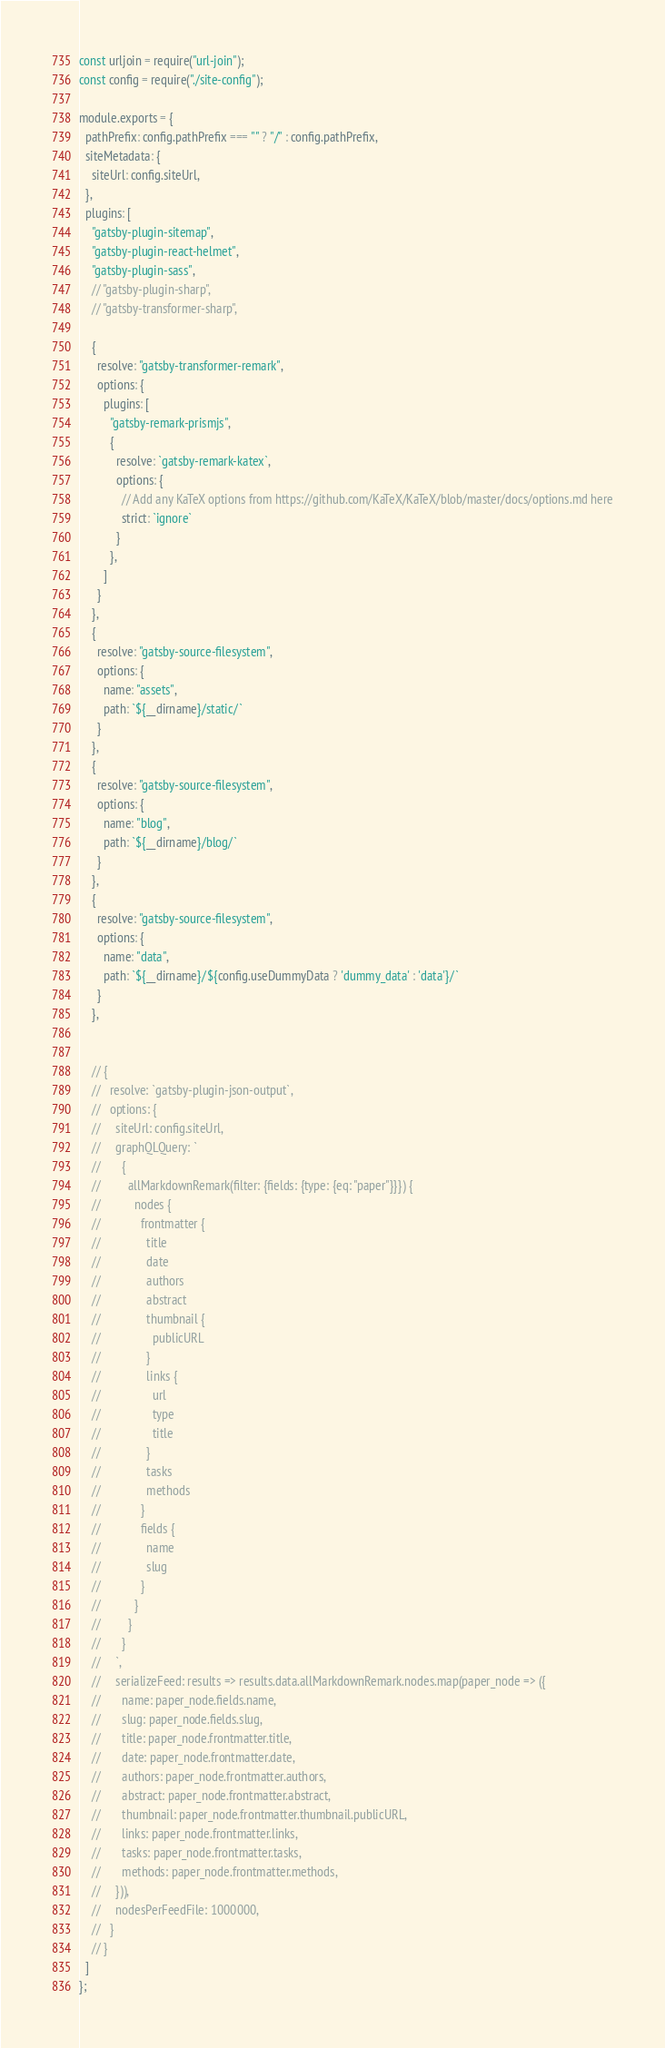<code> <loc_0><loc_0><loc_500><loc_500><_JavaScript_>const urljoin = require("url-join");
const config = require("./site-config");

module.exports = {
  pathPrefix: config.pathPrefix === "" ? "/" : config.pathPrefix,
  siteMetadata: {
    siteUrl: config.siteUrl,
  },
  plugins: [
    "gatsby-plugin-sitemap",
    "gatsby-plugin-react-helmet",
    "gatsby-plugin-sass",
    // "gatsby-plugin-sharp",
    // "gatsby-transformer-sharp",

    {
      resolve: "gatsby-transformer-remark",
      options: {
        plugins: [
          "gatsby-remark-prismjs",
          {
            resolve: `gatsby-remark-katex`,
            options: {
              // Add any KaTeX options from https://github.com/KaTeX/KaTeX/blob/master/docs/options.md here
              strict: `ignore`
            }
          },
        ]
      }
    },
    {
      resolve: "gatsby-source-filesystem",
      options: {
        name: "assets",
        path: `${__dirname}/static/`
      }
    },
    {
      resolve: "gatsby-source-filesystem",
      options: {
        name: "blog",
        path: `${__dirname}/blog/`
      }
    },
    {
      resolve: "gatsby-source-filesystem",
      options: {
        name: "data",
        path: `${__dirname}/${config.useDummyData ? 'dummy_data' : 'data'}/`
      }
    },

   
    // {
    //   resolve: `gatsby-plugin-json-output`,
    //   options: {
    //     siteUrl: config.siteUrl,
    //     graphQLQuery: `
    //       {
    //         allMarkdownRemark(filter: {fields: {type: {eq: "paper"}}}) {
    //           nodes {
    //             frontmatter {
    //               title
    //               date
    //               authors
    //               abstract
    //               thumbnail {
    //                 publicURL
    //               }
    //               links {
    //                 url
    //                 type
    //                 title
    //               }
    //               tasks
    //               methods
    //             }
    //             fields {
    //               name
    //               slug
    //             }
    //           }
    //         }
    //       }
    //     `,
    //     serializeFeed: results => results.data.allMarkdownRemark.nodes.map(paper_node => ({
    //       name: paper_node.fields.name,
    //       slug: paper_node.fields.slug,
    //       title: paper_node.frontmatter.title,
    //       date: paper_node.frontmatter.date,
    //       authors: paper_node.frontmatter.authors,
    //       abstract: paper_node.frontmatter.abstract,
    //       thumbnail: paper_node.frontmatter.thumbnail.publicURL,
    //       links: paper_node.frontmatter.links,
    //       tasks: paper_node.frontmatter.tasks,
    //       methods: paper_node.frontmatter.methods,
    //     })),
    //     nodesPerFeedFile: 1000000,
    //   }
    // }
  ]
};

</code> 